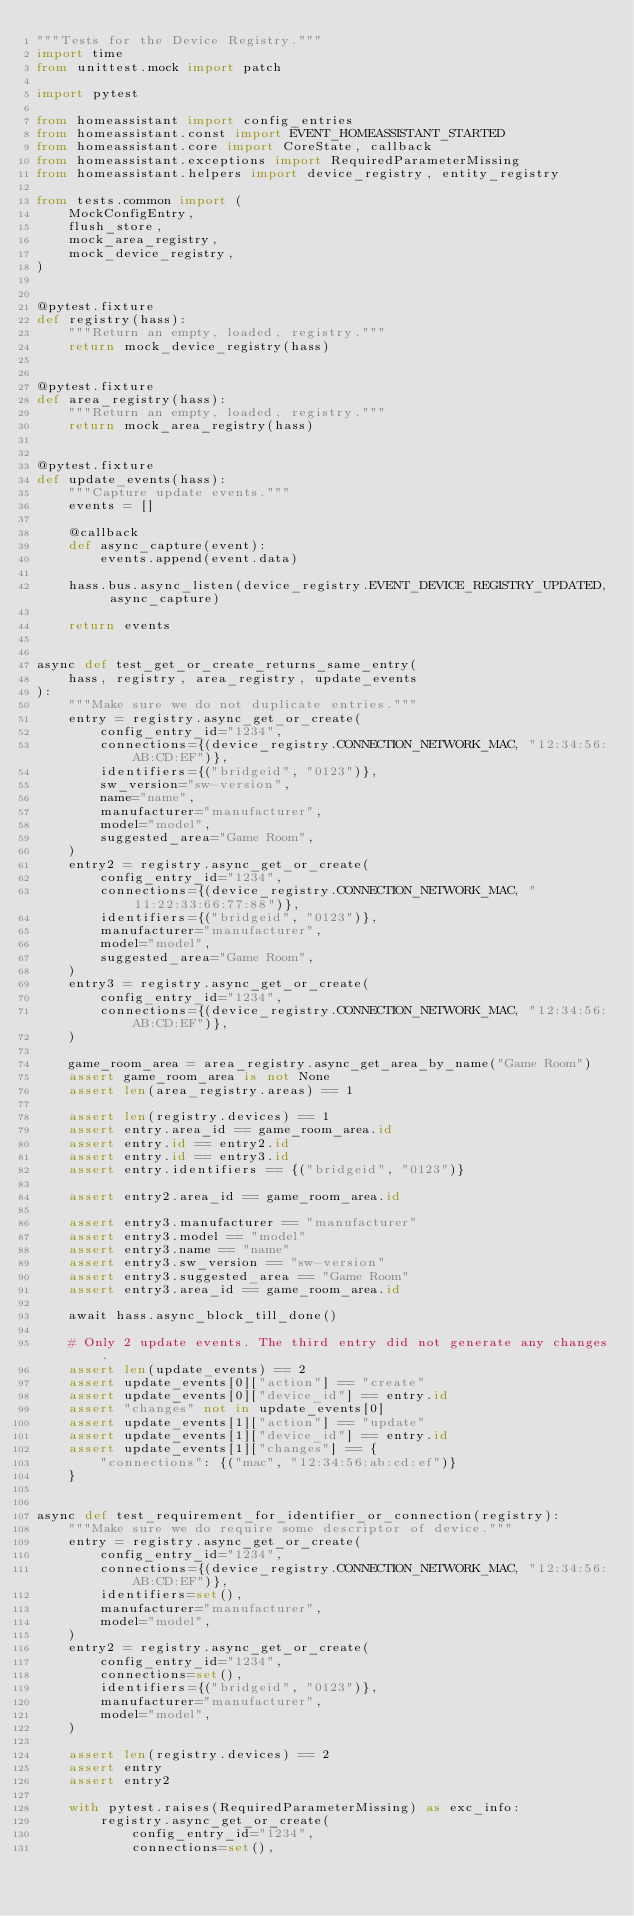<code> <loc_0><loc_0><loc_500><loc_500><_Python_>"""Tests for the Device Registry."""
import time
from unittest.mock import patch

import pytest

from homeassistant import config_entries
from homeassistant.const import EVENT_HOMEASSISTANT_STARTED
from homeassistant.core import CoreState, callback
from homeassistant.exceptions import RequiredParameterMissing
from homeassistant.helpers import device_registry, entity_registry

from tests.common import (
    MockConfigEntry,
    flush_store,
    mock_area_registry,
    mock_device_registry,
)


@pytest.fixture
def registry(hass):
    """Return an empty, loaded, registry."""
    return mock_device_registry(hass)


@pytest.fixture
def area_registry(hass):
    """Return an empty, loaded, registry."""
    return mock_area_registry(hass)


@pytest.fixture
def update_events(hass):
    """Capture update events."""
    events = []

    @callback
    def async_capture(event):
        events.append(event.data)

    hass.bus.async_listen(device_registry.EVENT_DEVICE_REGISTRY_UPDATED, async_capture)

    return events


async def test_get_or_create_returns_same_entry(
    hass, registry, area_registry, update_events
):
    """Make sure we do not duplicate entries."""
    entry = registry.async_get_or_create(
        config_entry_id="1234",
        connections={(device_registry.CONNECTION_NETWORK_MAC, "12:34:56:AB:CD:EF")},
        identifiers={("bridgeid", "0123")},
        sw_version="sw-version",
        name="name",
        manufacturer="manufacturer",
        model="model",
        suggested_area="Game Room",
    )
    entry2 = registry.async_get_or_create(
        config_entry_id="1234",
        connections={(device_registry.CONNECTION_NETWORK_MAC, "11:22:33:66:77:88")},
        identifiers={("bridgeid", "0123")},
        manufacturer="manufacturer",
        model="model",
        suggested_area="Game Room",
    )
    entry3 = registry.async_get_or_create(
        config_entry_id="1234",
        connections={(device_registry.CONNECTION_NETWORK_MAC, "12:34:56:AB:CD:EF")},
    )

    game_room_area = area_registry.async_get_area_by_name("Game Room")
    assert game_room_area is not None
    assert len(area_registry.areas) == 1

    assert len(registry.devices) == 1
    assert entry.area_id == game_room_area.id
    assert entry.id == entry2.id
    assert entry.id == entry3.id
    assert entry.identifiers == {("bridgeid", "0123")}

    assert entry2.area_id == game_room_area.id

    assert entry3.manufacturer == "manufacturer"
    assert entry3.model == "model"
    assert entry3.name == "name"
    assert entry3.sw_version == "sw-version"
    assert entry3.suggested_area == "Game Room"
    assert entry3.area_id == game_room_area.id

    await hass.async_block_till_done()

    # Only 2 update events. The third entry did not generate any changes.
    assert len(update_events) == 2
    assert update_events[0]["action"] == "create"
    assert update_events[0]["device_id"] == entry.id
    assert "changes" not in update_events[0]
    assert update_events[1]["action"] == "update"
    assert update_events[1]["device_id"] == entry.id
    assert update_events[1]["changes"] == {
        "connections": {("mac", "12:34:56:ab:cd:ef")}
    }


async def test_requirement_for_identifier_or_connection(registry):
    """Make sure we do require some descriptor of device."""
    entry = registry.async_get_or_create(
        config_entry_id="1234",
        connections={(device_registry.CONNECTION_NETWORK_MAC, "12:34:56:AB:CD:EF")},
        identifiers=set(),
        manufacturer="manufacturer",
        model="model",
    )
    entry2 = registry.async_get_or_create(
        config_entry_id="1234",
        connections=set(),
        identifiers={("bridgeid", "0123")},
        manufacturer="manufacturer",
        model="model",
    )

    assert len(registry.devices) == 2
    assert entry
    assert entry2

    with pytest.raises(RequiredParameterMissing) as exc_info:
        registry.async_get_or_create(
            config_entry_id="1234",
            connections=set(),</code> 